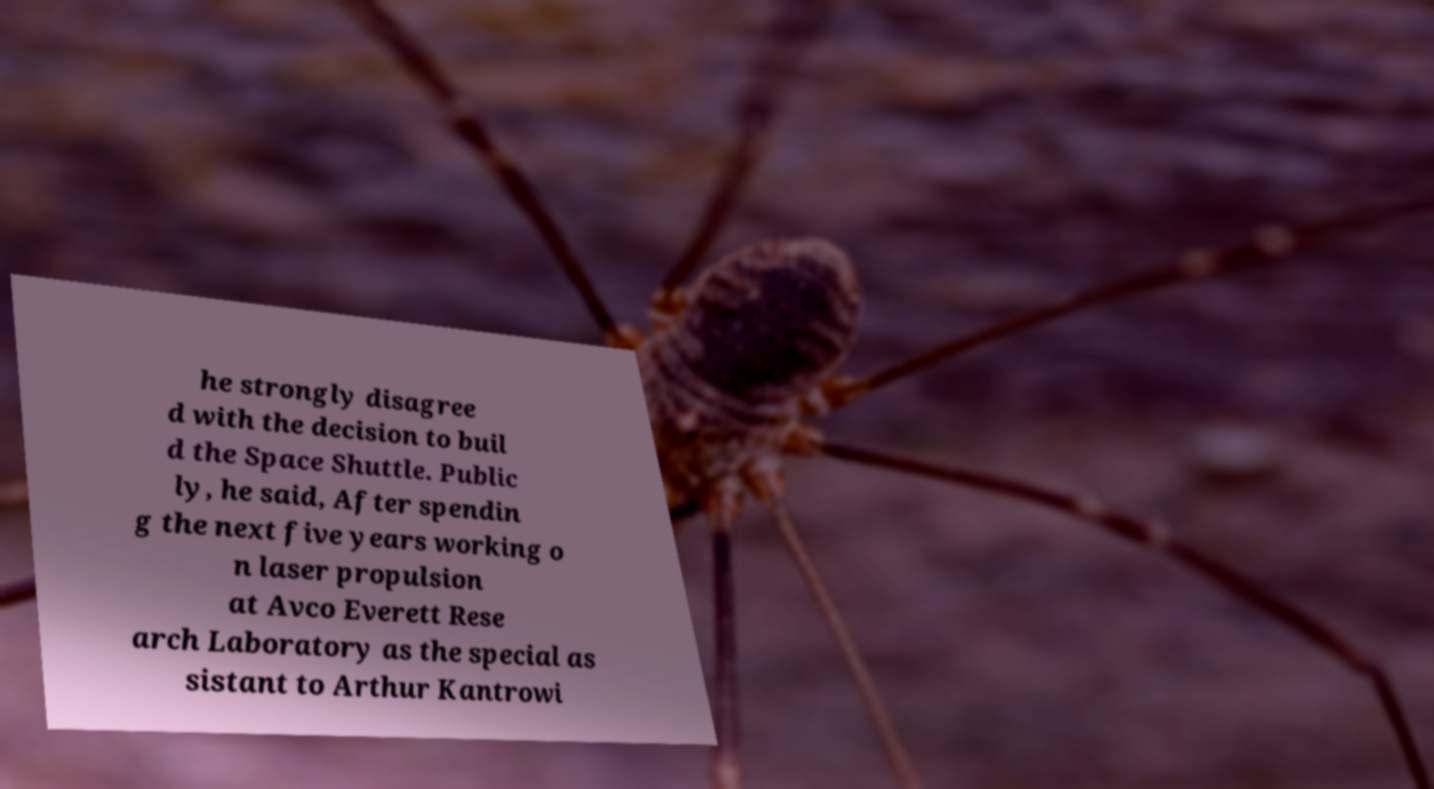Could you assist in decoding the text presented in this image and type it out clearly? he strongly disagree d with the decision to buil d the Space Shuttle. Public ly, he said, After spendin g the next five years working o n laser propulsion at Avco Everett Rese arch Laboratory as the special as sistant to Arthur Kantrowi 